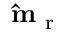Convert formula to latex. <formula><loc_0><loc_0><loc_500><loc_500>\hat { m } _ { r }</formula> 